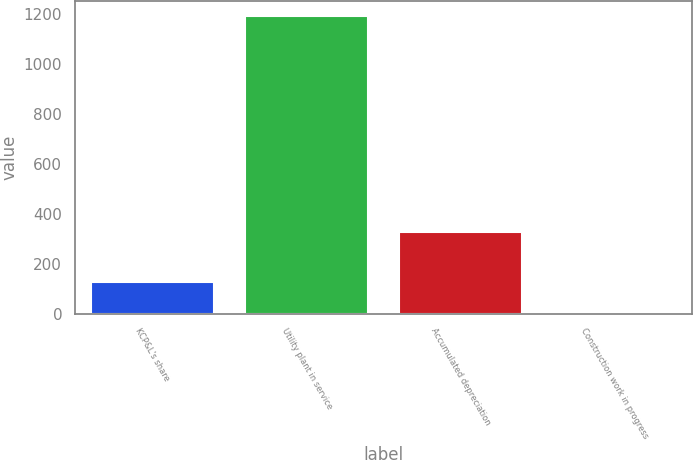<chart> <loc_0><loc_0><loc_500><loc_500><bar_chart><fcel>KCP&L's share<fcel>Utility plant in service<fcel>Accumulated depreciation<fcel>Construction work in progress<nl><fcel>126.47<fcel>1194.5<fcel>328.5<fcel>7.8<nl></chart> 